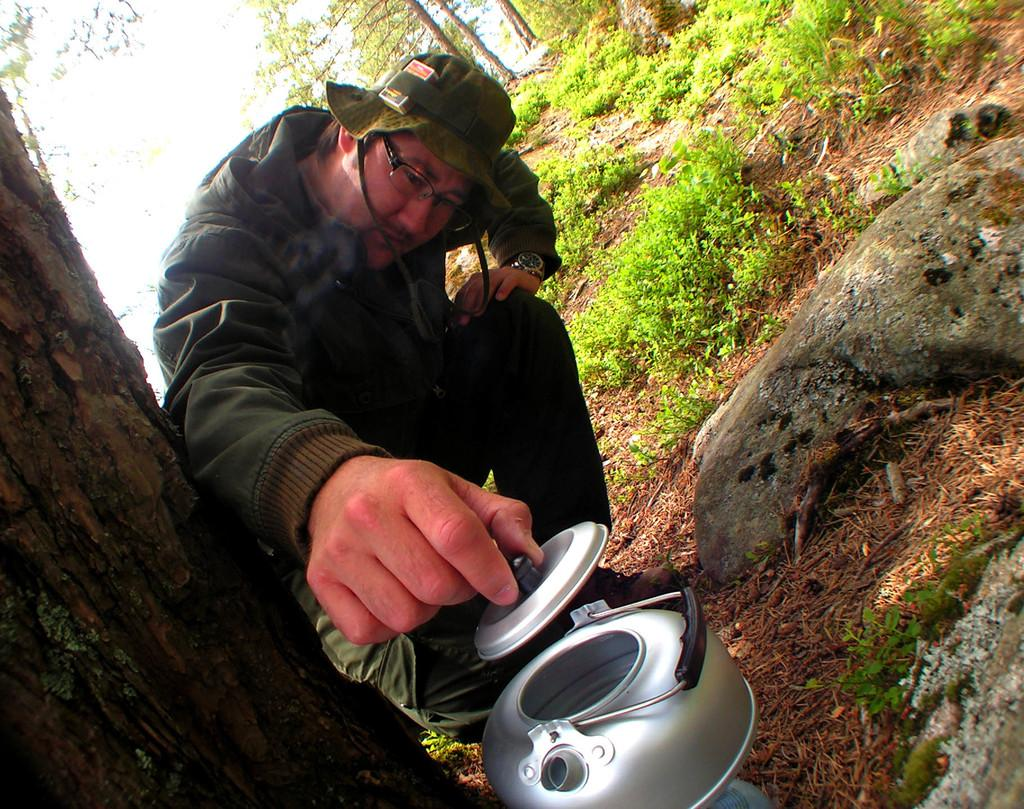What is the person in the image doing? The person is sitting on the ground in the image. What is the person holding in their hands? The person is holding a cooking vessel in their hands. What can be seen in the background of the image? There are rocks, grass, trees, and the sky visible in the background of the image. What is the rate of the stamp collection in the image? There is no stamp collection present in the image, so it is not possible to determine the rate. 